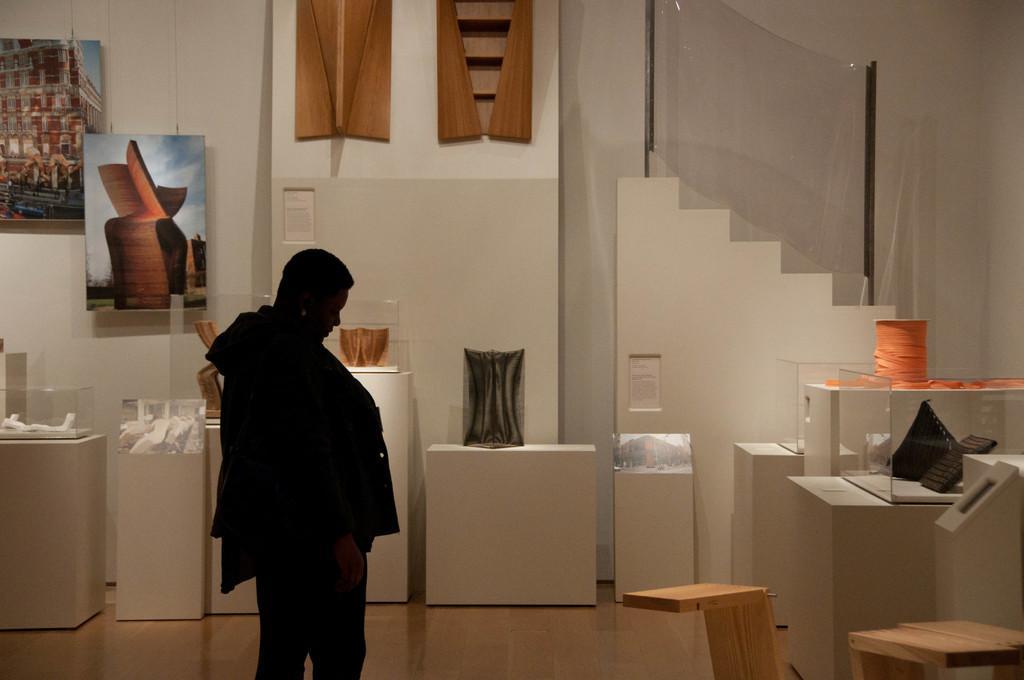Can you describe this image briefly? In this picture we can see a woman, in front of her we can see few things on the tables, and we can find few paintings on the wall. 